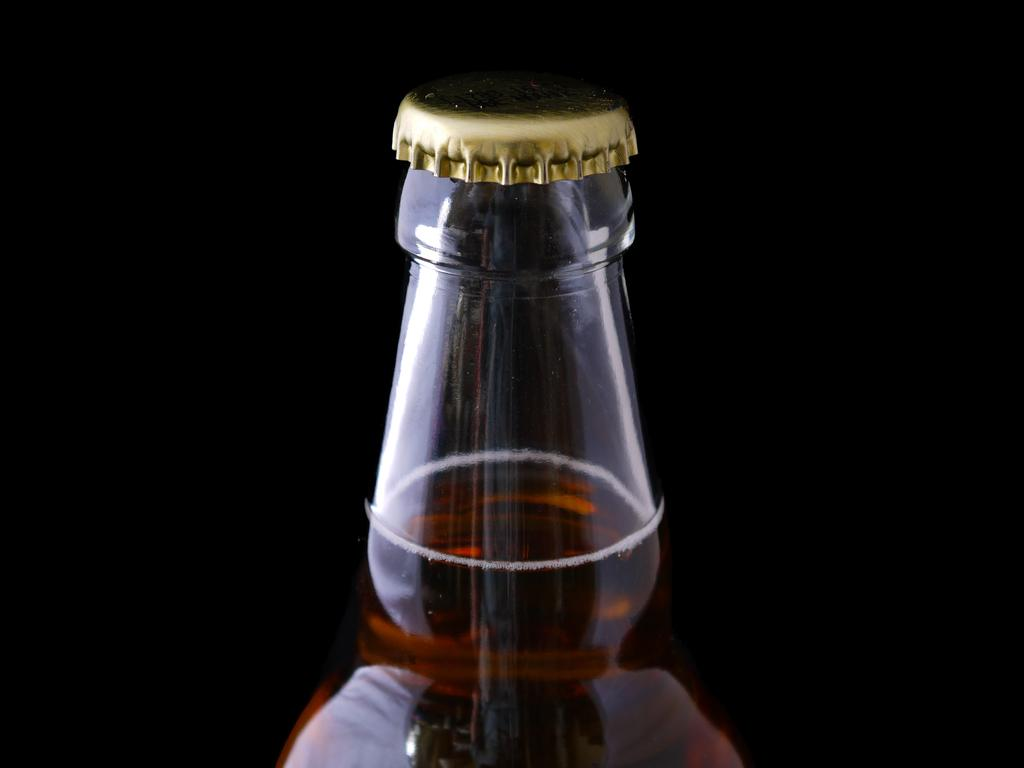What is the main object in the image? There is a bottle of wine in the image. Can you describe the bottle of wine in more detail? The bottle of wine has a golden cap. What type of knee surgery is being performed in the image? There is no knee or surgery present in the image; it only features a bottle of wine with a golden cap. 